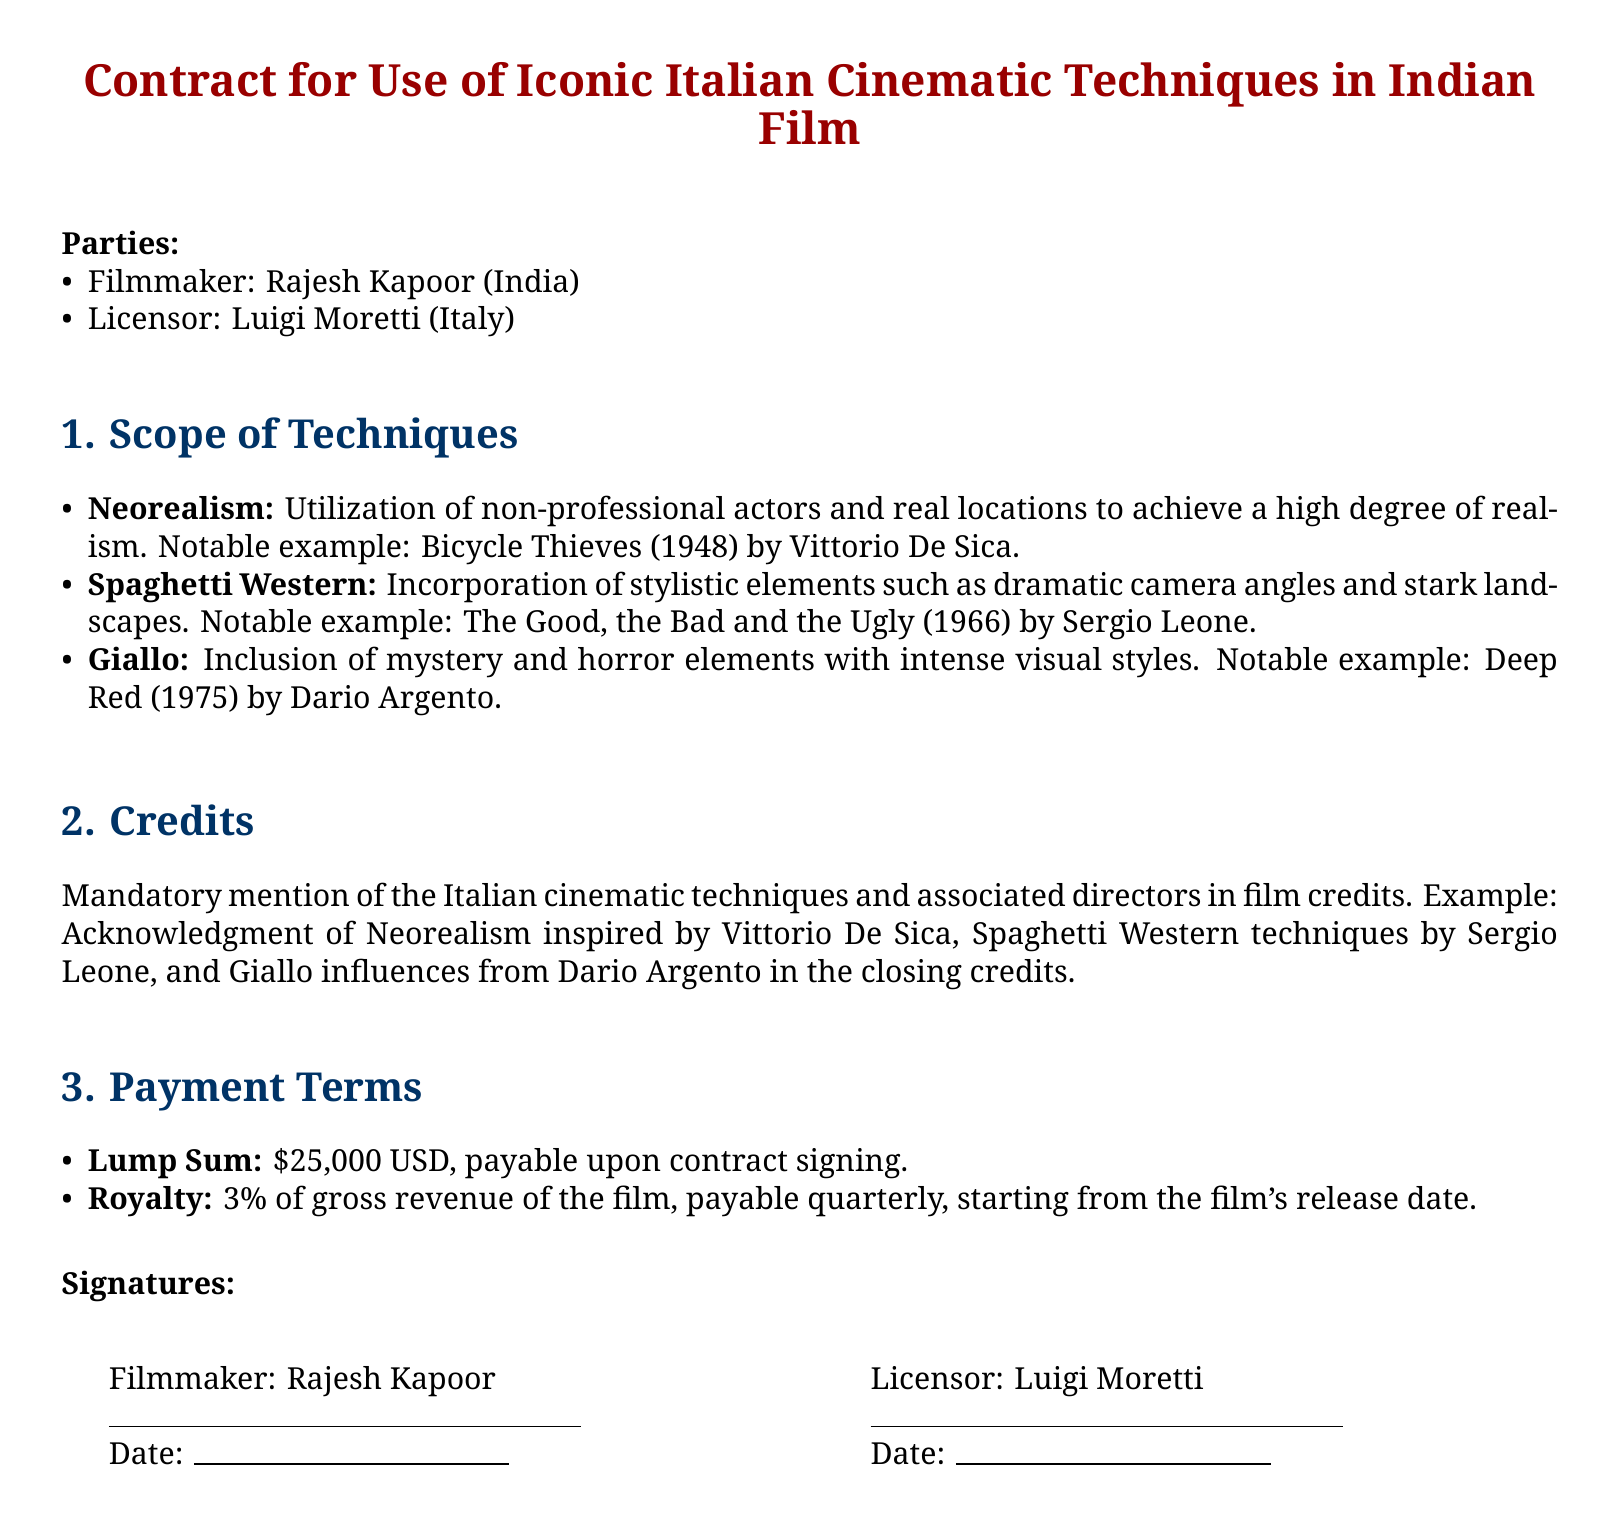What is the name of the filmmaker? The document states that the filmmaker's name is Rajesh Kapoor.
Answer: Rajesh Kapoor Who is the licensor? The licensor mentioned in the document is Luigi Moretti.
Answer: Luigi Moretti What is the payment amount upon contract signing? The document specifies a lump sum payment of $25,000 USD upon contract signing.
Answer: $25,000 USD How much is the royalty percentage of gross revenue? The document states that the royalty is 3% of the gross revenue of the film.
Answer: 3% What is the total number of cinematic techniques listed? There are three cinematic techniques detailed in the document.
Answer: 3 Which iconic technique is associated with "Bicycle Thieves"? The technique associated with "Bicycle Thieves" is Neorealism.
Answer: Neorealism What is the nature of the techniques used in the film credits? The credits must include a mandatory mention of the cinematic techniques and associated directors.
Answer: Mandatory mention What is the payment frequency for the royalty? The document indicates that the royalty payments are to be made quarterly.
Answer: Quarterly Name one example of a Giallo film. The document provides "Deep Red" as an example of a Giallo film.
Answer: Deep Red 